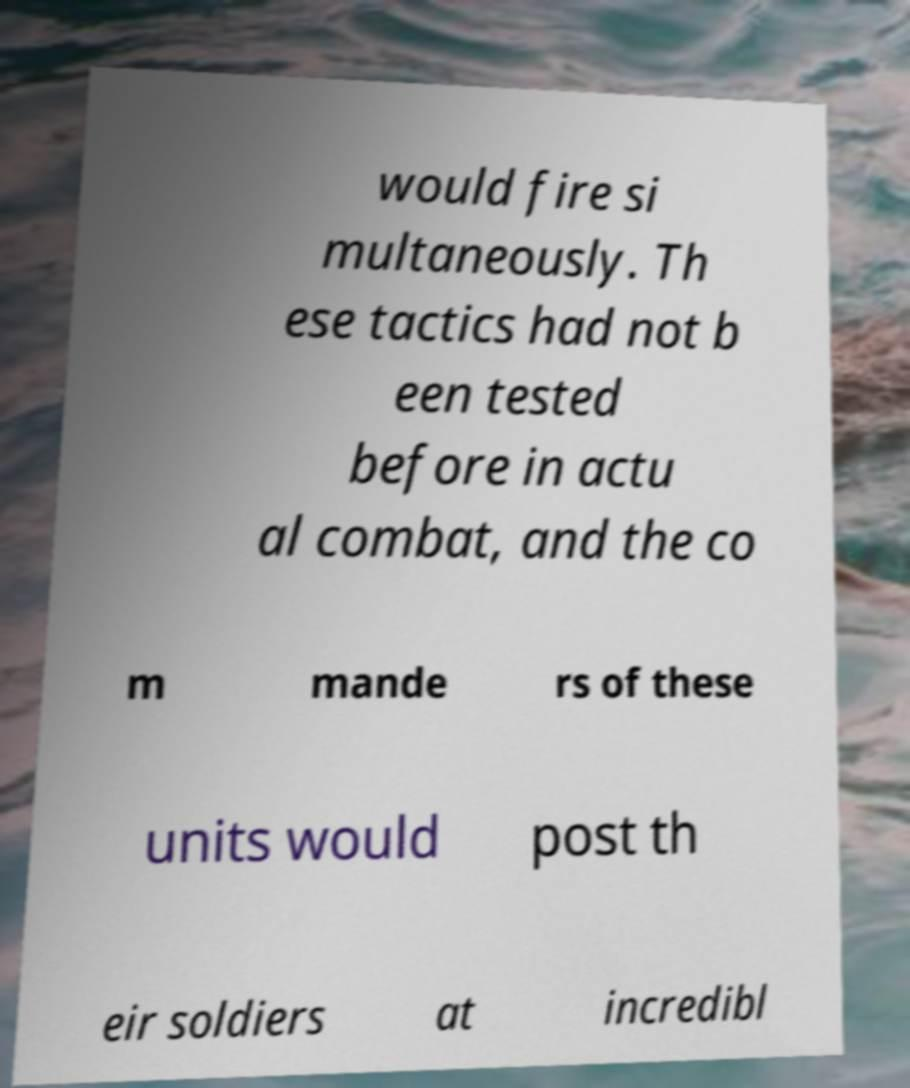There's text embedded in this image that I need extracted. Can you transcribe it verbatim? would fire si multaneously. Th ese tactics had not b een tested before in actu al combat, and the co m mande rs of these units would post th eir soldiers at incredibl 